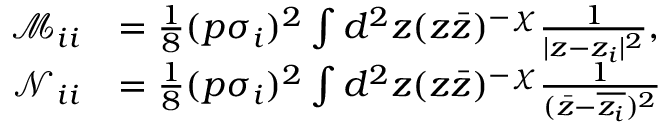Convert formula to latex. <formula><loc_0><loc_0><loc_500><loc_500>\begin{array} { r l } { \mathcal { M } _ { i i } } & { = \frac { 1 } { 8 } ( p \sigma _ { i } ) ^ { 2 } \int d ^ { 2 } z ( z \bar { z } ) ^ { - \chi } \frac { 1 } { | z - z _ { i } | ^ { 2 } } , } \\ { \mathcal { N } _ { i i } } & { = \frac { 1 } { 8 } ( p \sigma _ { i } ) ^ { 2 } \int d ^ { 2 } z ( z \bar { z } ) ^ { - \chi } \frac { 1 } { ( \bar { z } - \overline { { z _ { i } } } ) ^ { 2 } } } \end{array}</formula> 